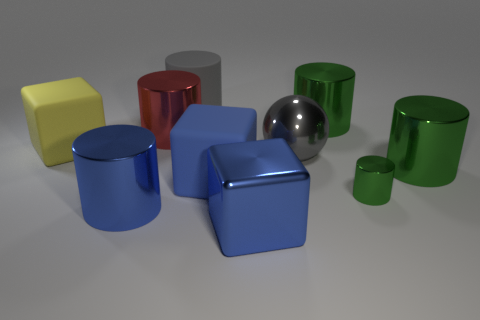The red metallic thing that is the same size as the gray metal object is what shape? The red metallic object, which is comparable in size to the gray metal object, is cylindrical in shape, featuring smooth curved surfaces and circular ends, typical of a cylinder. 